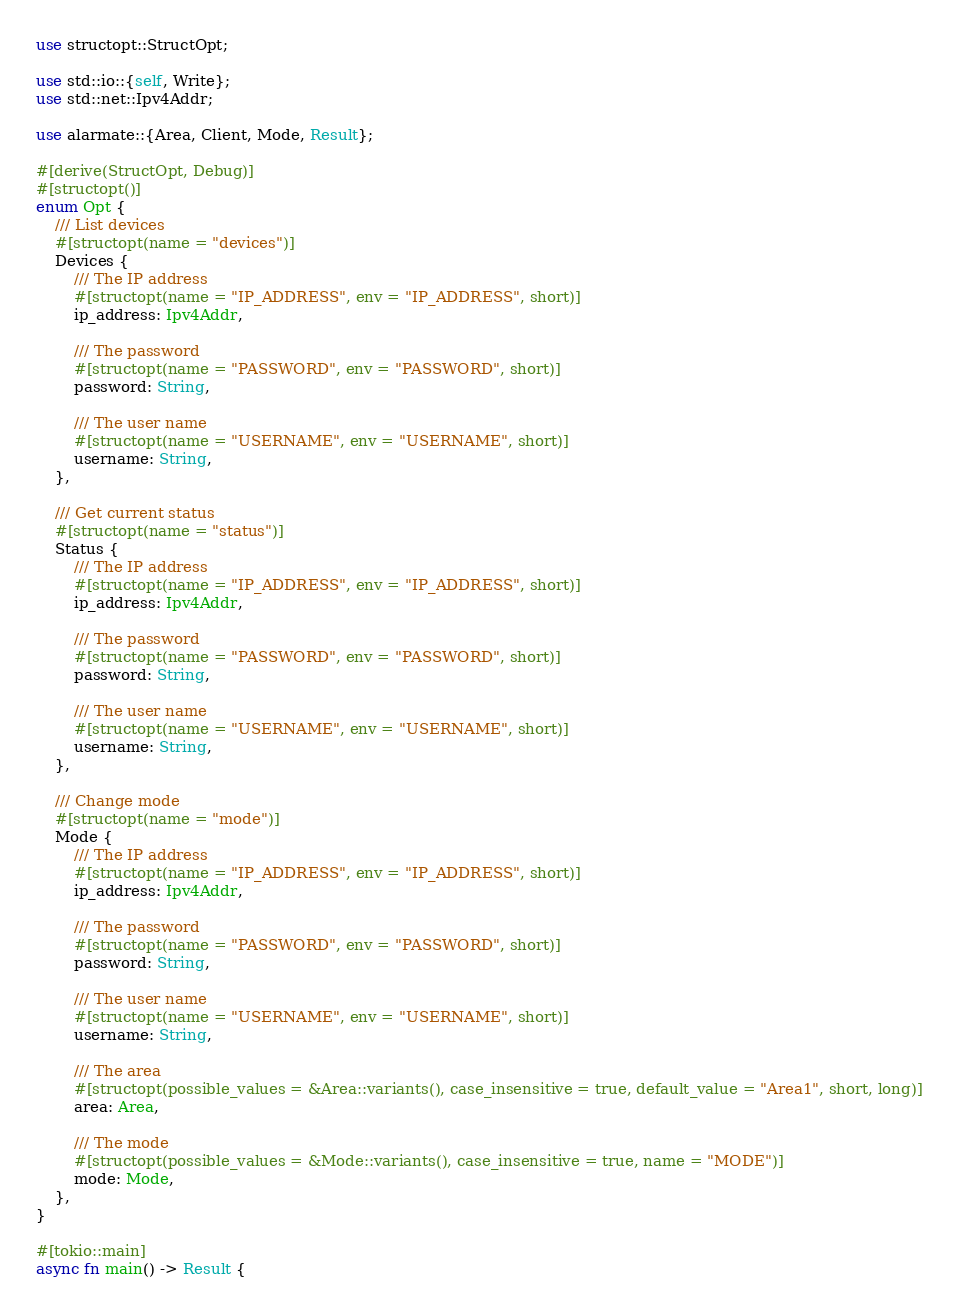<code> <loc_0><loc_0><loc_500><loc_500><_Rust_>use structopt::StructOpt;

use std::io::{self, Write};
use std::net::Ipv4Addr;

use alarmate::{Area, Client, Mode, Result};

#[derive(StructOpt, Debug)]
#[structopt()]
enum Opt {
    /// List devices
    #[structopt(name = "devices")]
    Devices {
        /// The IP address
        #[structopt(name = "IP_ADDRESS", env = "IP_ADDRESS", short)]
        ip_address: Ipv4Addr,

        /// The password
        #[structopt(name = "PASSWORD", env = "PASSWORD", short)]
        password: String,

        /// The user name
        #[structopt(name = "USERNAME", env = "USERNAME", short)]
        username: String,
    },

    /// Get current status
    #[structopt(name = "status")]
    Status {
        /// The IP address
        #[structopt(name = "IP_ADDRESS", env = "IP_ADDRESS", short)]
        ip_address: Ipv4Addr,

        /// The password
        #[structopt(name = "PASSWORD", env = "PASSWORD", short)]
        password: String,

        /// The user name
        #[structopt(name = "USERNAME", env = "USERNAME", short)]
        username: String,
    },

    /// Change mode
    #[structopt(name = "mode")]
    Mode {
        /// The IP address
        #[structopt(name = "IP_ADDRESS", env = "IP_ADDRESS", short)]
        ip_address: Ipv4Addr,

        /// The password
        #[structopt(name = "PASSWORD", env = "PASSWORD", short)]
        password: String,

        /// The user name
        #[structopt(name = "USERNAME", env = "USERNAME", short)]
        username: String,

        /// The area
        #[structopt(possible_values = &Area::variants(), case_insensitive = true, default_value = "Area1", short, long)]
        area: Area,

        /// The mode
        #[structopt(possible_values = &Mode::variants(), case_insensitive = true, name = "MODE")]
        mode: Mode,
    },
}

#[tokio::main]
async fn main() -> Result {</code> 